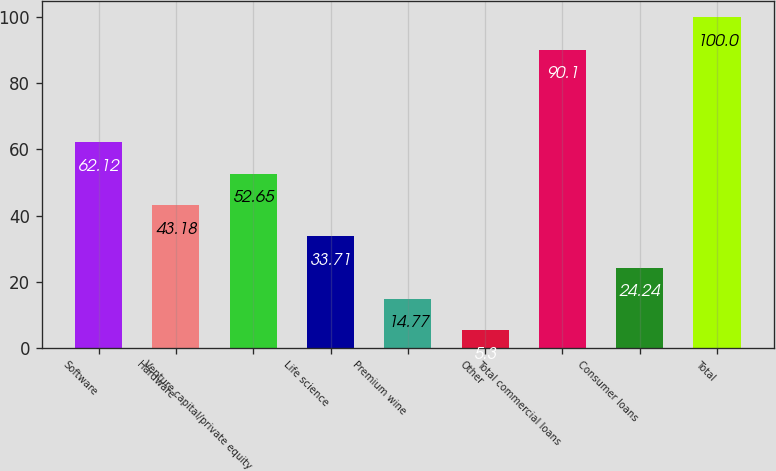Convert chart to OTSL. <chart><loc_0><loc_0><loc_500><loc_500><bar_chart><fcel>Software<fcel>Hardware<fcel>Venture capital/private equity<fcel>Life science<fcel>Premium wine<fcel>Other<fcel>Total commercial loans<fcel>Consumer loans<fcel>Total<nl><fcel>62.12<fcel>43.18<fcel>52.65<fcel>33.71<fcel>14.77<fcel>5.3<fcel>90.1<fcel>24.24<fcel>100<nl></chart> 